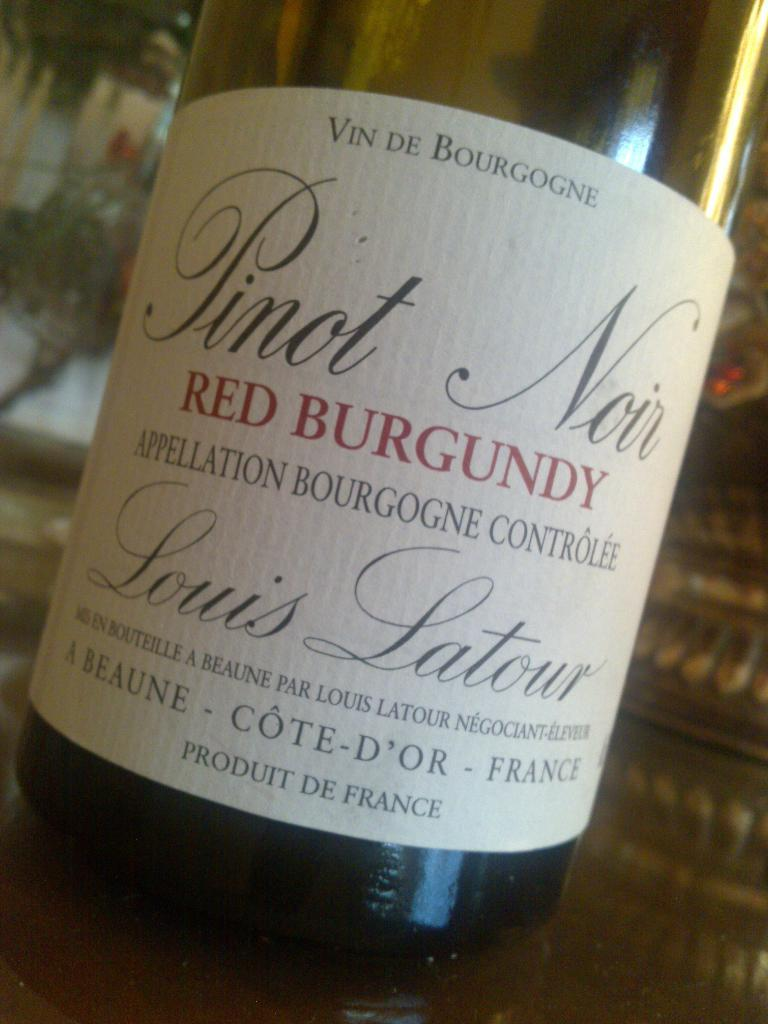What object can be seen in the image? There is a bottle in the image. Is there anything on the bottle? Yes, there is a sticker on the bottle. What type of calculator is on the side of the bottle? There is no calculator present on the side of the bottle in the image. Can you see a kitty playing with the sticker on the bottle? There is no kitty present in the image. 